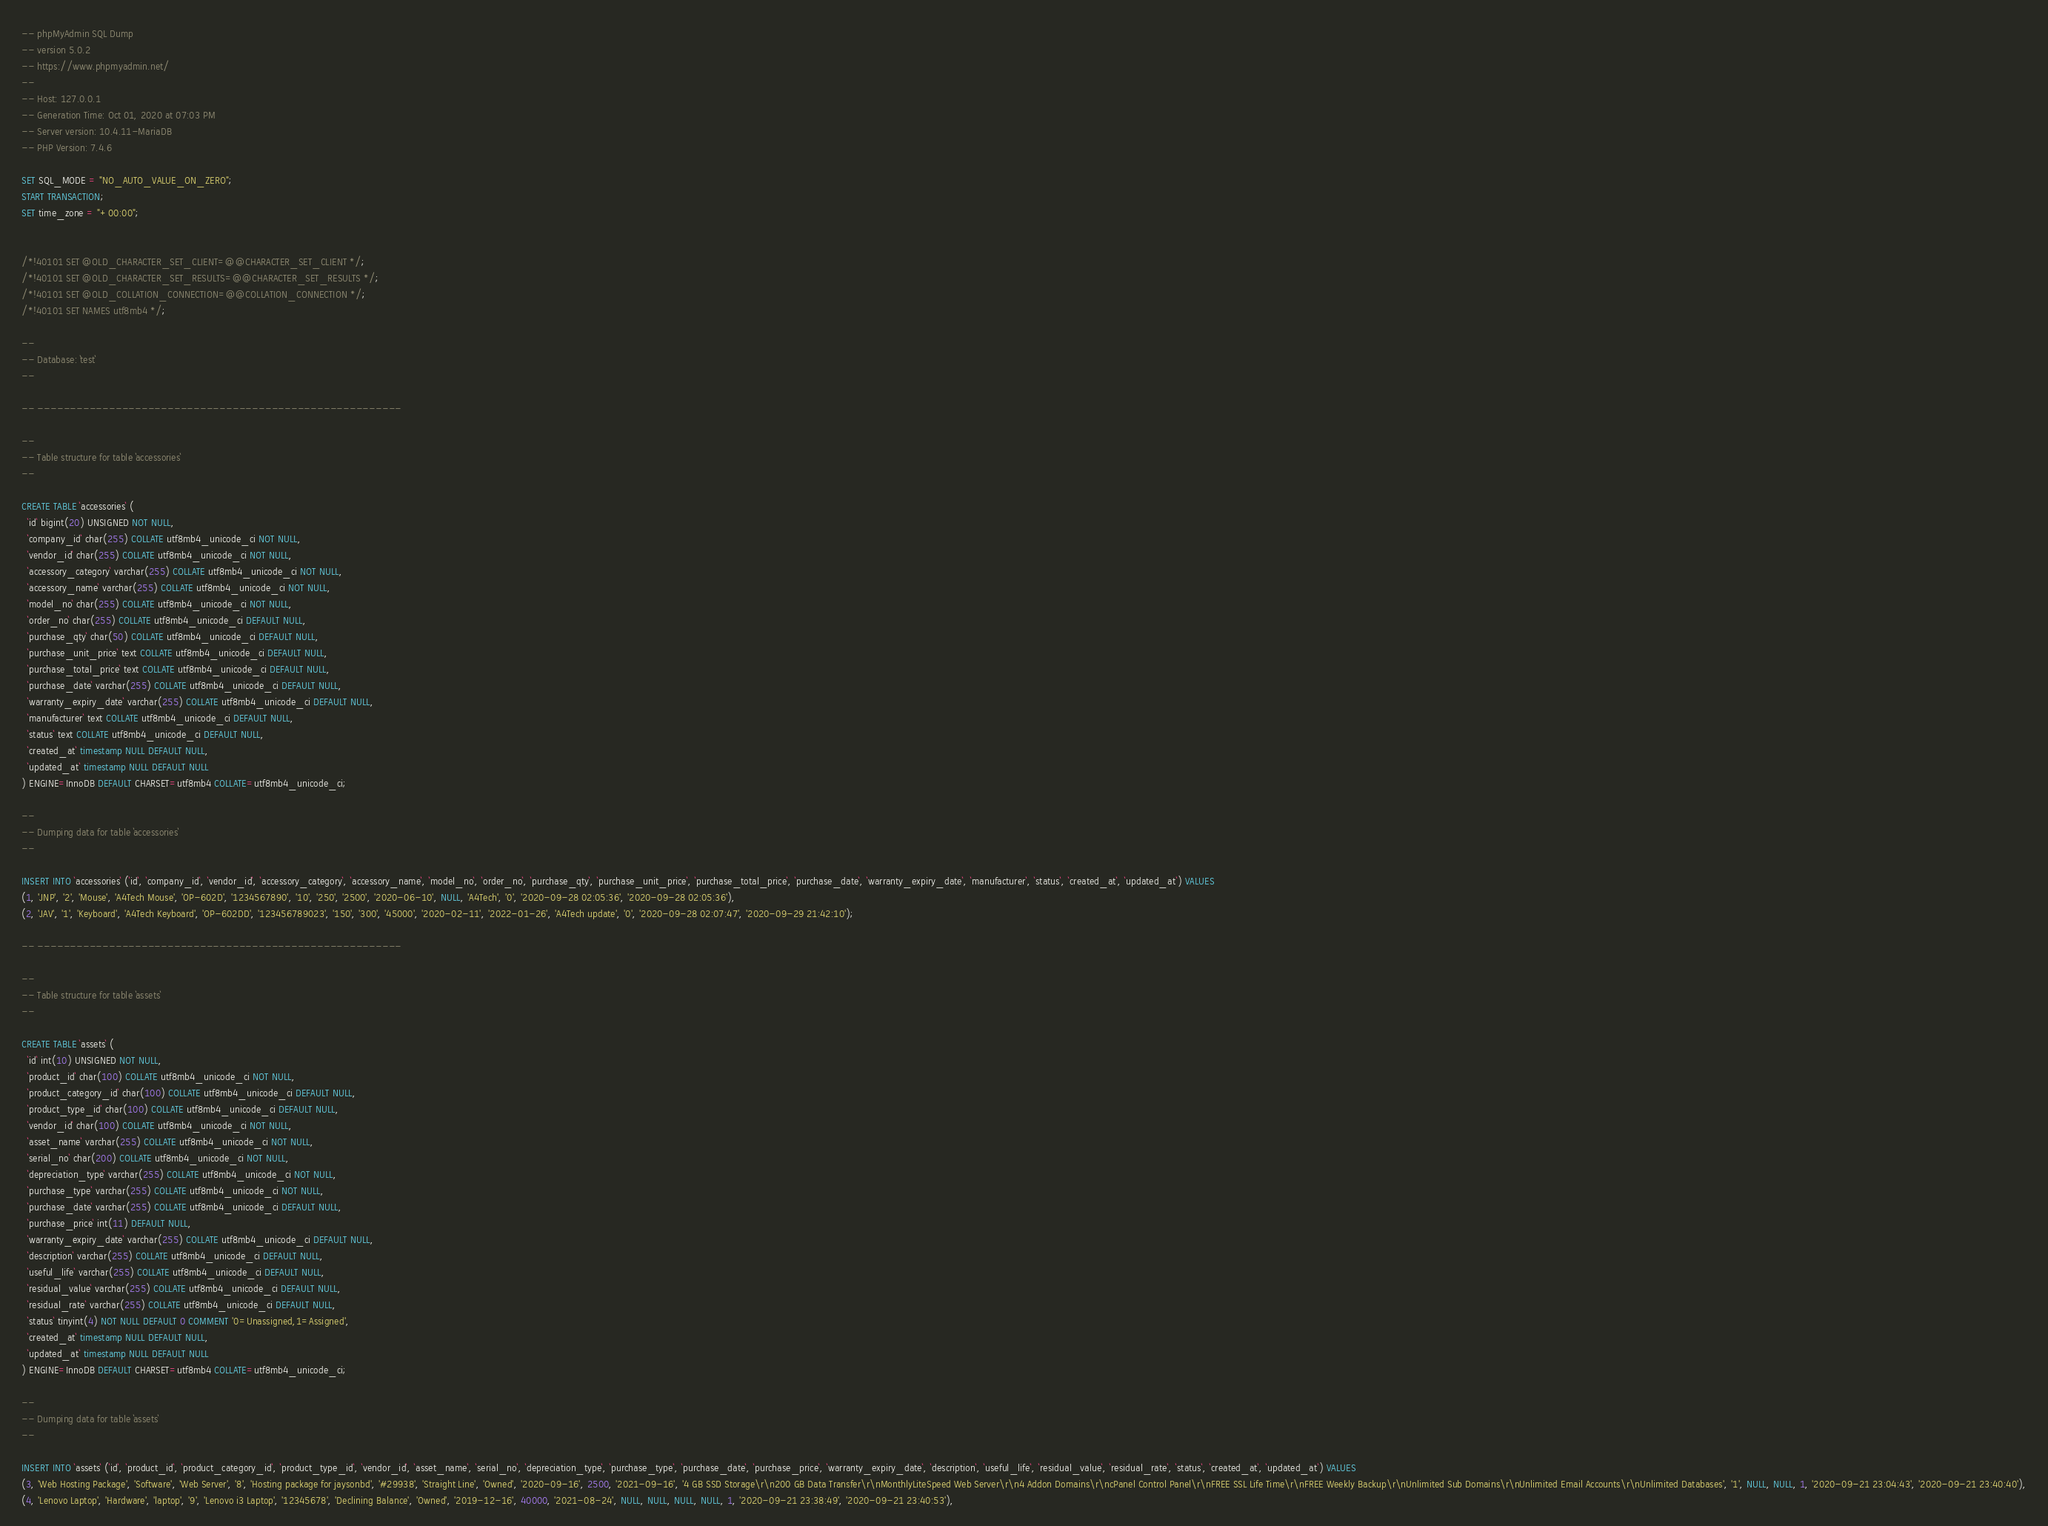Convert code to text. <code><loc_0><loc_0><loc_500><loc_500><_SQL_>-- phpMyAdmin SQL Dump
-- version 5.0.2
-- https://www.phpmyadmin.net/
--
-- Host: 127.0.0.1
-- Generation Time: Oct 01, 2020 at 07:03 PM
-- Server version: 10.4.11-MariaDB
-- PHP Version: 7.4.6

SET SQL_MODE = "NO_AUTO_VALUE_ON_ZERO";
START TRANSACTION;
SET time_zone = "+00:00";


/*!40101 SET @OLD_CHARACTER_SET_CLIENT=@@CHARACTER_SET_CLIENT */;
/*!40101 SET @OLD_CHARACTER_SET_RESULTS=@@CHARACTER_SET_RESULTS */;
/*!40101 SET @OLD_COLLATION_CONNECTION=@@COLLATION_CONNECTION */;
/*!40101 SET NAMES utf8mb4 */;

--
-- Database: `test`
--

-- --------------------------------------------------------

--
-- Table structure for table `accessories`
--

CREATE TABLE `accessories` (
  `id` bigint(20) UNSIGNED NOT NULL,
  `company_id` char(255) COLLATE utf8mb4_unicode_ci NOT NULL,
  `vendor_id` char(255) COLLATE utf8mb4_unicode_ci NOT NULL,
  `accessory_category` varchar(255) COLLATE utf8mb4_unicode_ci NOT NULL,
  `accessory_name` varchar(255) COLLATE utf8mb4_unicode_ci NOT NULL,
  `model_no` char(255) COLLATE utf8mb4_unicode_ci NOT NULL,
  `order_no` char(255) COLLATE utf8mb4_unicode_ci DEFAULT NULL,
  `purchase_qty` char(50) COLLATE utf8mb4_unicode_ci DEFAULT NULL,
  `purchase_unit_price` text COLLATE utf8mb4_unicode_ci DEFAULT NULL,
  `purchase_total_price` text COLLATE utf8mb4_unicode_ci DEFAULT NULL,
  `purchase_date` varchar(255) COLLATE utf8mb4_unicode_ci DEFAULT NULL,
  `warranty_expiry_date` varchar(255) COLLATE utf8mb4_unicode_ci DEFAULT NULL,
  `manufacturer` text COLLATE utf8mb4_unicode_ci DEFAULT NULL,
  `status` text COLLATE utf8mb4_unicode_ci DEFAULT NULL,
  `created_at` timestamp NULL DEFAULT NULL,
  `updated_at` timestamp NULL DEFAULT NULL
) ENGINE=InnoDB DEFAULT CHARSET=utf8mb4 COLLATE=utf8mb4_unicode_ci;

--
-- Dumping data for table `accessories`
--

INSERT INTO `accessories` (`id`, `company_id`, `vendor_id`, `accessory_category`, `accessory_name`, `model_no`, `order_no`, `purchase_qty`, `purchase_unit_price`, `purchase_total_price`, `purchase_date`, `warranty_expiry_date`, `manufacturer`, `status`, `created_at`, `updated_at`) VALUES
(1, 'JNP', '2', 'Mouse', 'A4Tech Mouse', 'OP-602D', '1234567890', '10', '250', '2500', '2020-06-10', NULL, 'A4Tech', '0', '2020-09-28 02:05:36', '2020-09-28 02:05:36'),
(2, 'JAV', '1', 'Keyboard', 'A4Tech Keyboard', 'OP-602DD', '123456789023', '150', '300', '45000', '2020-02-11', '2022-01-26', 'A4Tech update', '0', '2020-09-28 02:07:47', '2020-09-29 21:42:10');

-- --------------------------------------------------------

--
-- Table structure for table `assets`
--

CREATE TABLE `assets` (
  `id` int(10) UNSIGNED NOT NULL,
  `product_id` char(100) COLLATE utf8mb4_unicode_ci NOT NULL,
  `product_category_id` char(100) COLLATE utf8mb4_unicode_ci DEFAULT NULL,
  `product_type_id` char(100) COLLATE utf8mb4_unicode_ci DEFAULT NULL,
  `vendor_id` char(100) COLLATE utf8mb4_unicode_ci NOT NULL,
  `asset_name` varchar(255) COLLATE utf8mb4_unicode_ci NOT NULL,
  `serial_no` char(200) COLLATE utf8mb4_unicode_ci NOT NULL,
  `depreciation_type` varchar(255) COLLATE utf8mb4_unicode_ci NOT NULL,
  `purchase_type` varchar(255) COLLATE utf8mb4_unicode_ci NOT NULL,
  `purchase_date` varchar(255) COLLATE utf8mb4_unicode_ci DEFAULT NULL,
  `purchase_price` int(11) DEFAULT NULL,
  `warranty_expiry_date` varchar(255) COLLATE utf8mb4_unicode_ci DEFAULT NULL,
  `description` varchar(255) COLLATE utf8mb4_unicode_ci DEFAULT NULL,
  `useful_life` varchar(255) COLLATE utf8mb4_unicode_ci DEFAULT NULL,
  `residual_value` varchar(255) COLLATE utf8mb4_unicode_ci DEFAULT NULL,
  `residual_rate` varchar(255) COLLATE utf8mb4_unicode_ci DEFAULT NULL,
  `status` tinyint(4) NOT NULL DEFAULT 0 COMMENT '0=Unassigned,1=Assigned',
  `created_at` timestamp NULL DEFAULT NULL,
  `updated_at` timestamp NULL DEFAULT NULL
) ENGINE=InnoDB DEFAULT CHARSET=utf8mb4 COLLATE=utf8mb4_unicode_ci;

--
-- Dumping data for table `assets`
--

INSERT INTO `assets` (`id`, `product_id`, `product_category_id`, `product_type_id`, `vendor_id`, `asset_name`, `serial_no`, `depreciation_type`, `purchase_type`, `purchase_date`, `purchase_price`, `warranty_expiry_date`, `description`, `useful_life`, `residual_value`, `residual_rate`, `status`, `created_at`, `updated_at`) VALUES
(3, 'Web Hosting Package', 'Software', 'Web Server', '8', 'Hosting package for jaysonbd', '#29938', 'Straight Line', 'Owned', '2020-09-16', 2500, '2021-09-16', '4 GB SSD Storage\r\n200 GB Data Transfer\r\nMonthlyLiteSpeed Web Server\r\n4 Addon Domains\r\ncPanel Control Panel\r\nFREE SSL Life Time\r\nFREE Weekly Backup\r\nUnlimited Sub Domains\r\nUnlimited Email Accounts\r\nUnlimited Databases', '1', NULL, NULL, 1, '2020-09-21 23:04:43', '2020-09-21 23:40:40'),
(4, 'Lenovo Laptop', 'Hardware', 'laptop', '9', 'Lenovo i3 Laptop', '12345678', 'Declining Balance', 'Owned', '2019-12-16', 40000, '2021-08-24', NULL, NULL, NULL, NULL, 1, '2020-09-21 23:38:49', '2020-09-21 23:40:53'),</code> 